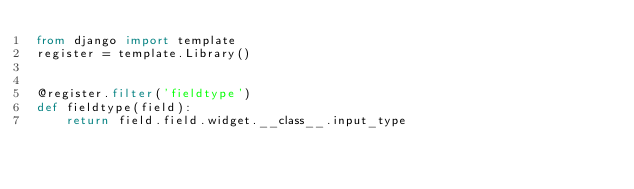Convert code to text. <code><loc_0><loc_0><loc_500><loc_500><_Python_>from django import template
register = template.Library()


@register.filter('fieldtype')
def fieldtype(field):
    return field.field.widget.__class__.input_type</code> 